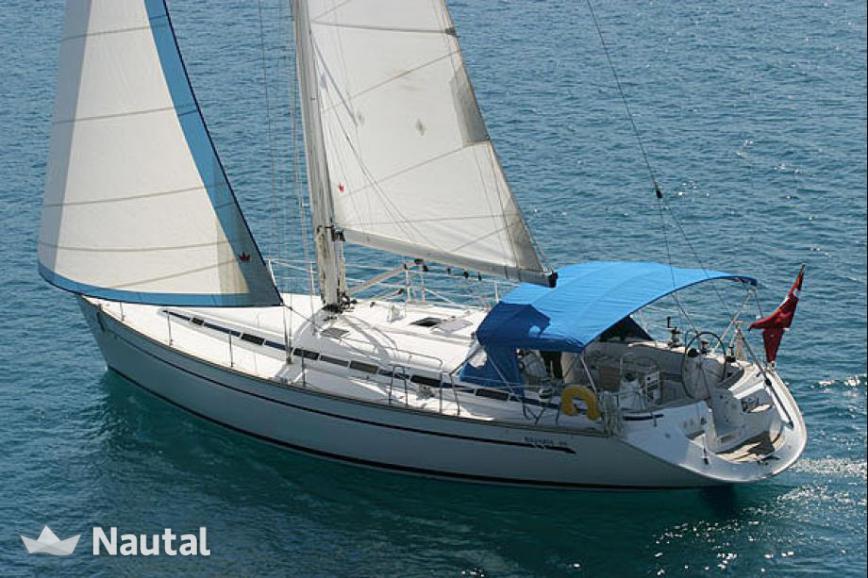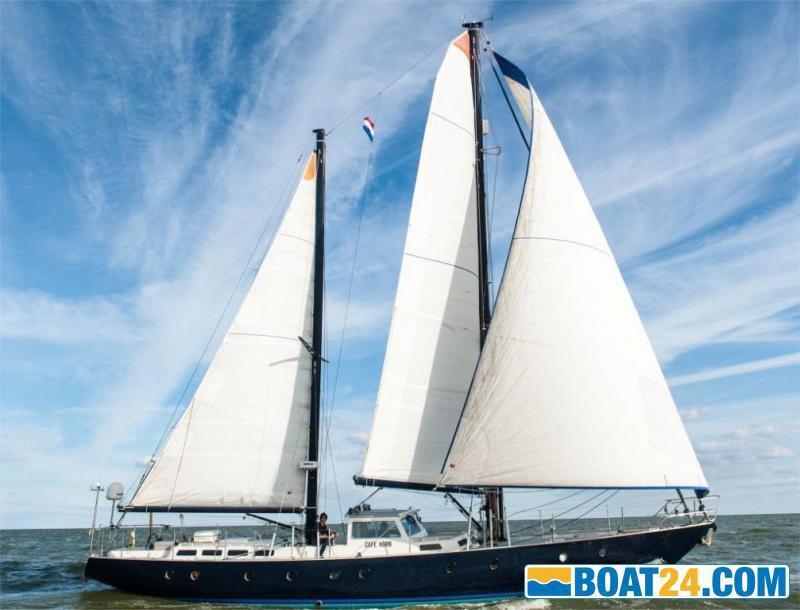The first image is the image on the left, the second image is the image on the right. Examine the images to the left and right. Is the description "There is one sailboat without the sails unfurled." accurate? Answer yes or no. No. 